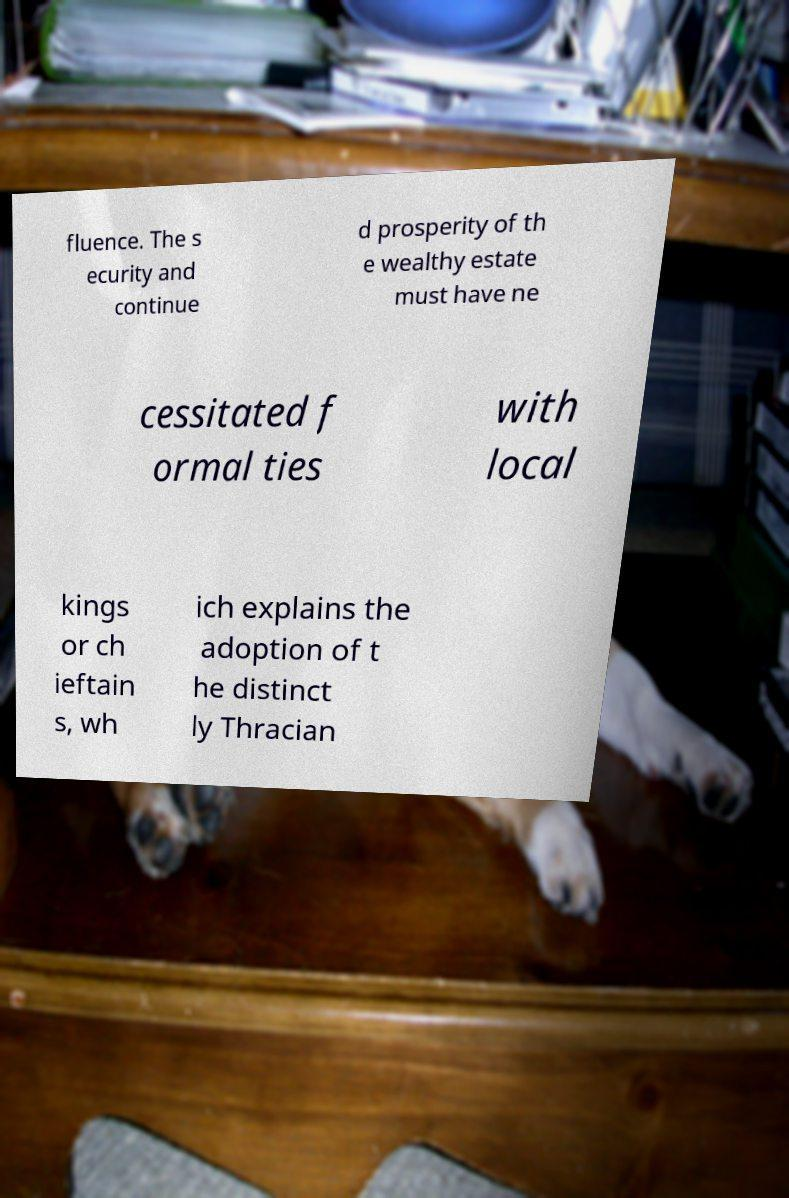I need the written content from this picture converted into text. Can you do that? fluence. The s ecurity and continue d prosperity of th e wealthy estate must have ne cessitated f ormal ties with local kings or ch ieftain s, wh ich explains the adoption of t he distinct ly Thracian 